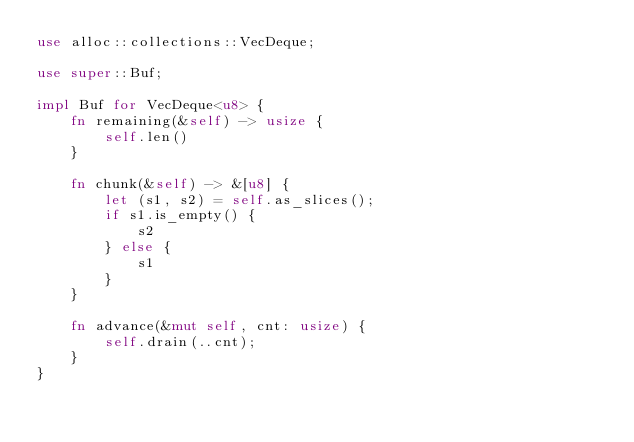Convert code to text. <code><loc_0><loc_0><loc_500><loc_500><_Rust_>use alloc::collections::VecDeque;

use super::Buf;

impl Buf for VecDeque<u8> {
    fn remaining(&self) -> usize {
        self.len()
    }

    fn chunk(&self) -> &[u8] {
        let (s1, s2) = self.as_slices();
        if s1.is_empty() {
            s2
        } else {
            s1
        }
    }

    fn advance(&mut self, cnt: usize) {
        self.drain(..cnt);
    }
}
</code> 